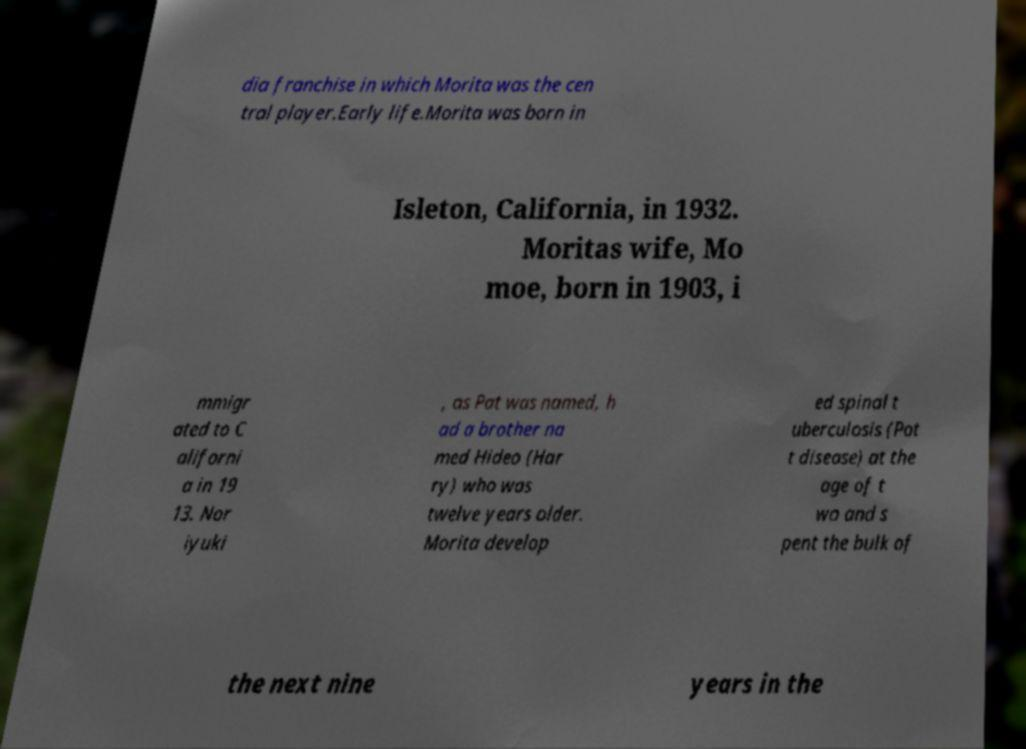I need the written content from this picture converted into text. Can you do that? dia franchise in which Morita was the cen tral player.Early life.Morita was born in Isleton, California, in 1932. Moritas wife, Mo moe, born in 1903, i mmigr ated to C aliforni a in 19 13. Nor iyuki , as Pat was named, h ad a brother na med Hideo (Har ry) who was twelve years older. Morita develop ed spinal t uberculosis (Pot t disease) at the age of t wo and s pent the bulk of the next nine years in the 